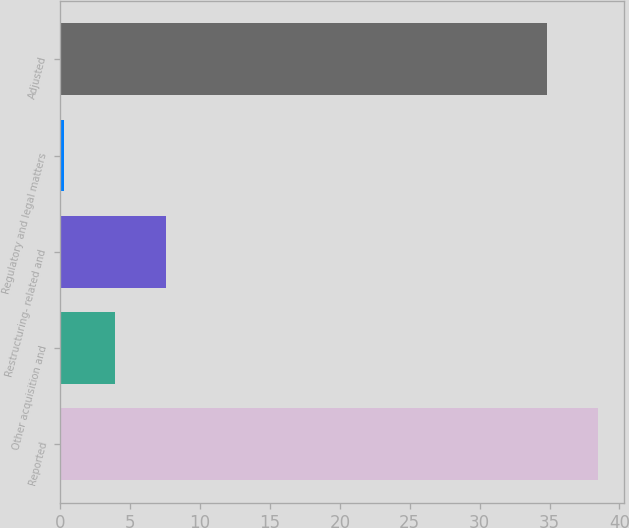Convert chart. <chart><loc_0><loc_0><loc_500><loc_500><bar_chart><fcel>Reported<fcel>Other acquisition and<fcel>Restructuring- related and<fcel>Regulatory and legal matters<fcel>Adjusted<nl><fcel>38.43<fcel>3.93<fcel>7.56<fcel>0.3<fcel>34.8<nl></chart> 